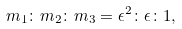<formula> <loc_0><loc_0><loc_500><loc_500>m _ { 1 } \colon m _ { 2 } \colon m _ { 3 } = \epsilon ^ { 2 } \colon \epsilon \colon 1 ,</formula> 